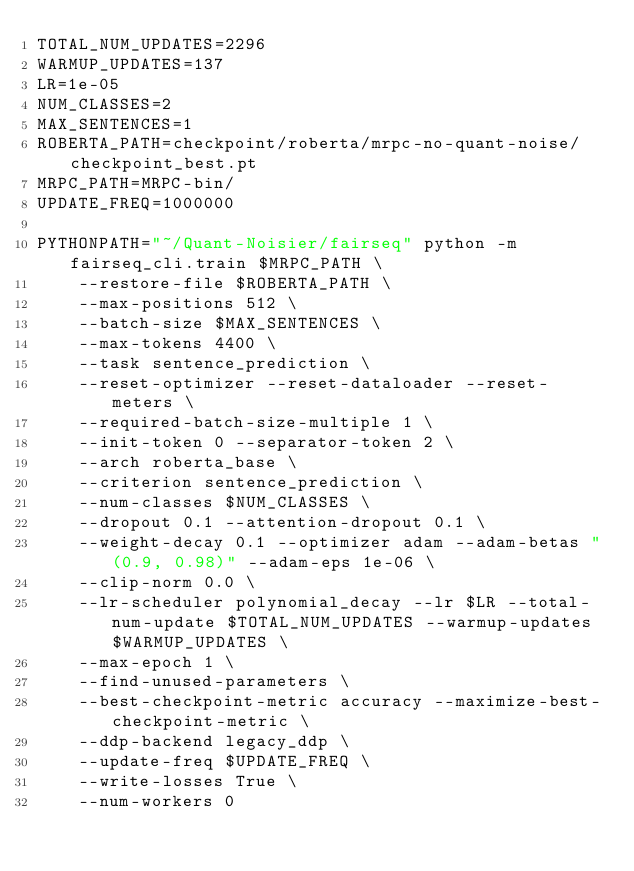<code> <loc_0><loc_0><loc_500><loc_500><_Bash_>TOTAL_NUM_UPDATES=2296
WARMUP_UPDATES=137
LR=1e-05
NUM_CLASSES=2
MAX_SENTENCES=1
ROBERTA_PATH=checkpoint/roberta/mrpc-no-quant-noise/checkpoint_best.pt
MRPC_PATH=MRPC-bin/
UPDATE_FREQ=1000000

PYTHONPATH="~/Quant-Noisier/fairseq" python -m fairseq_cli.train $MRPC_PATH \
    --restore-file $ROBERTA_PATH \
    --max-positions 512 \
    --batch-size $MAX_SENTENCES \
    --max-tokens 4400 \
    --task sentence_prediction \
    --reset-optimizer --reset-dataloader --reset-meters \
    --required-batch-size-multiple 1 \
    --init-token 0 --separator-token 2 \
    --arch roberta_base \
    --criterion sentence_prediction \
    --num-classes $NUM_CLASSES \
    --dropout 0.1 --attention-dropout 0.1 \
    --weight-decay 0.1 --optimizer adam --adam-betas "(0.9, 0.98)" --adam-eps 1e-06 \
    --clip-norm 0.0 \
    --lr-scheduler polynomial_decay --lr $LR --total-num-update $TOTAL_NUM_UPDATES --warmup-updates $WARMUP_UPDATES \
    --max-epoch 1 \
    --find-unused-parameters \
    --best-checkpoint-metric accuracy --maximize-best-checkpoint-metric \
    --ddp-backend legacy_ddp \
    --update-freq $UPDATE_FREQ \
    --write-losses True \
    --num-workers 0 </code> 